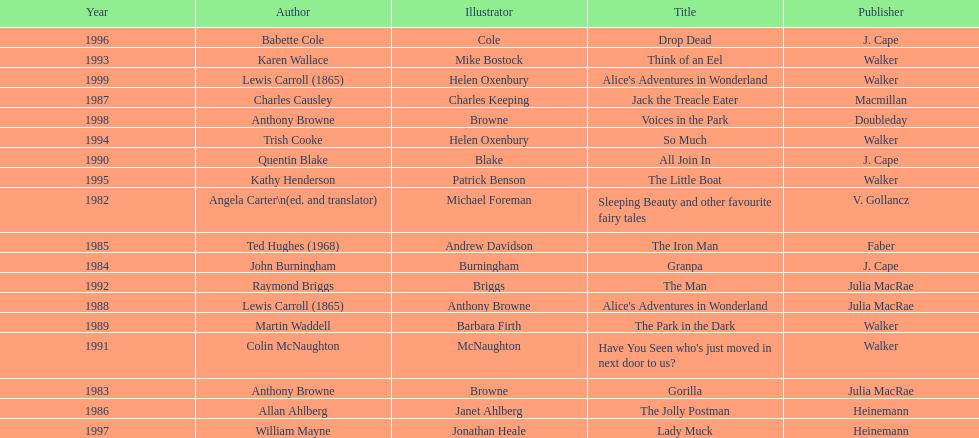How many total titles were published by walker? 5. 